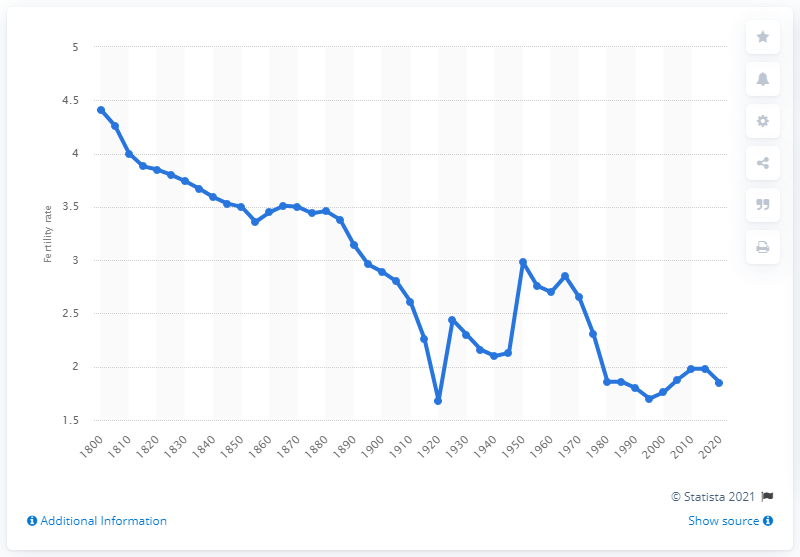Give some essential details in this illustration. In 1995, France's fertility rate reached its lowest point. In 1920, the fertility rate in France was 1.7. 